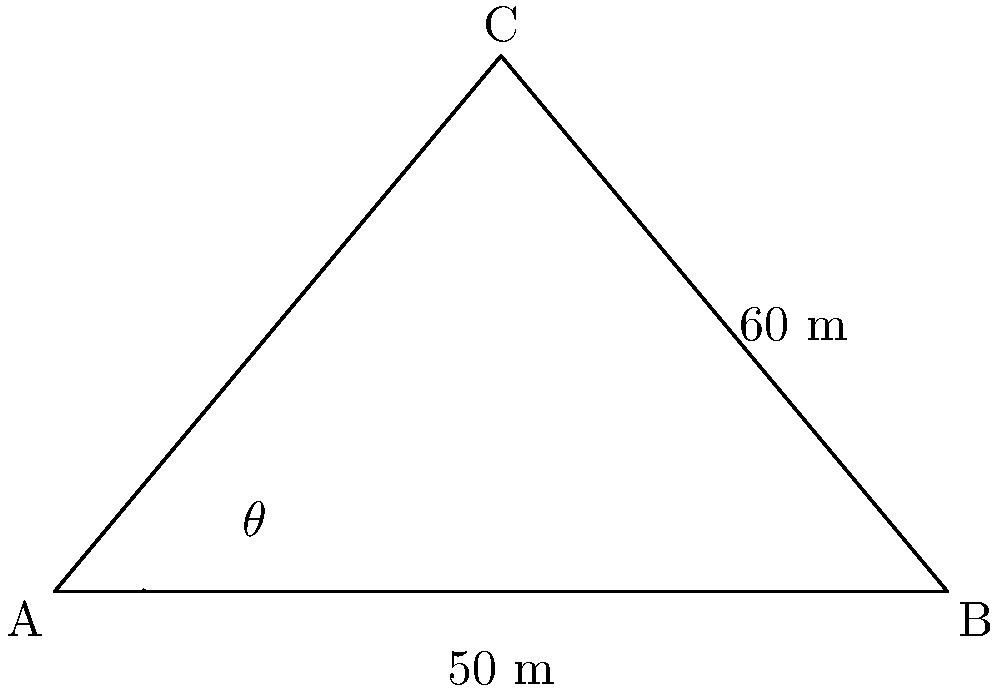A bridge support structure forms a right triangle with the ground. The base of the triangle is 100 meters long, and the support beam extends 60 meters vertically from the midpoint of the base. To maximize stability, the angle $\theta$ between the support beam and the ground needs to be determined. Calculate the optimal angle $\theta$ in degrees. Let's approach this step-by-step:

1) First, we need to identify the triangle formed by the support structure. We have a right triangle where:
   - The base (ground) is 100 meters
   - The height (vertical support) is 60 meters
   - The support beam forms the hypotenuse

2) We're interested in the angle $\theta$ between the support beam and the ground. This angle is formed at point A.

3) To find this angle, we can use the tangent function. In a right triangle:

   $\tan(\theta) = \frac{\text{opposite}}{\text{adjacent}}$

4) In our case:
   - The opposite side is the vertical support: 60 meters
   - The adjacent side is half the base length: 50 meters (since the vertical support is at the midpoint)

5) So, we can write:

   $\tan(\theta) = \frac{60}{50} = 1.2$

6) To find $\theta$, we need to take the inverse tangent (arctan or $\tan^{-1}$):

   $\theta = \tan^{-1}(1.2)$

7) Using a calculator or trigonometric tables:

   $\theta \approx 50.19°$

Therefore, the optimal angle for the support beam is approximately 50.19 degrees.
Answer: $50.19°$ 